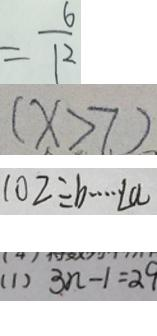Convert formula to latex. <formula><loc_0><loc_0><loc_500><loc_500>= \frac { 6 } { 1 2 } 
 ( x > 7 ) 
 1 0 2 \div b \cdots L a 
 ( 1 ) 3 n - 1 = 2 9</formula> 